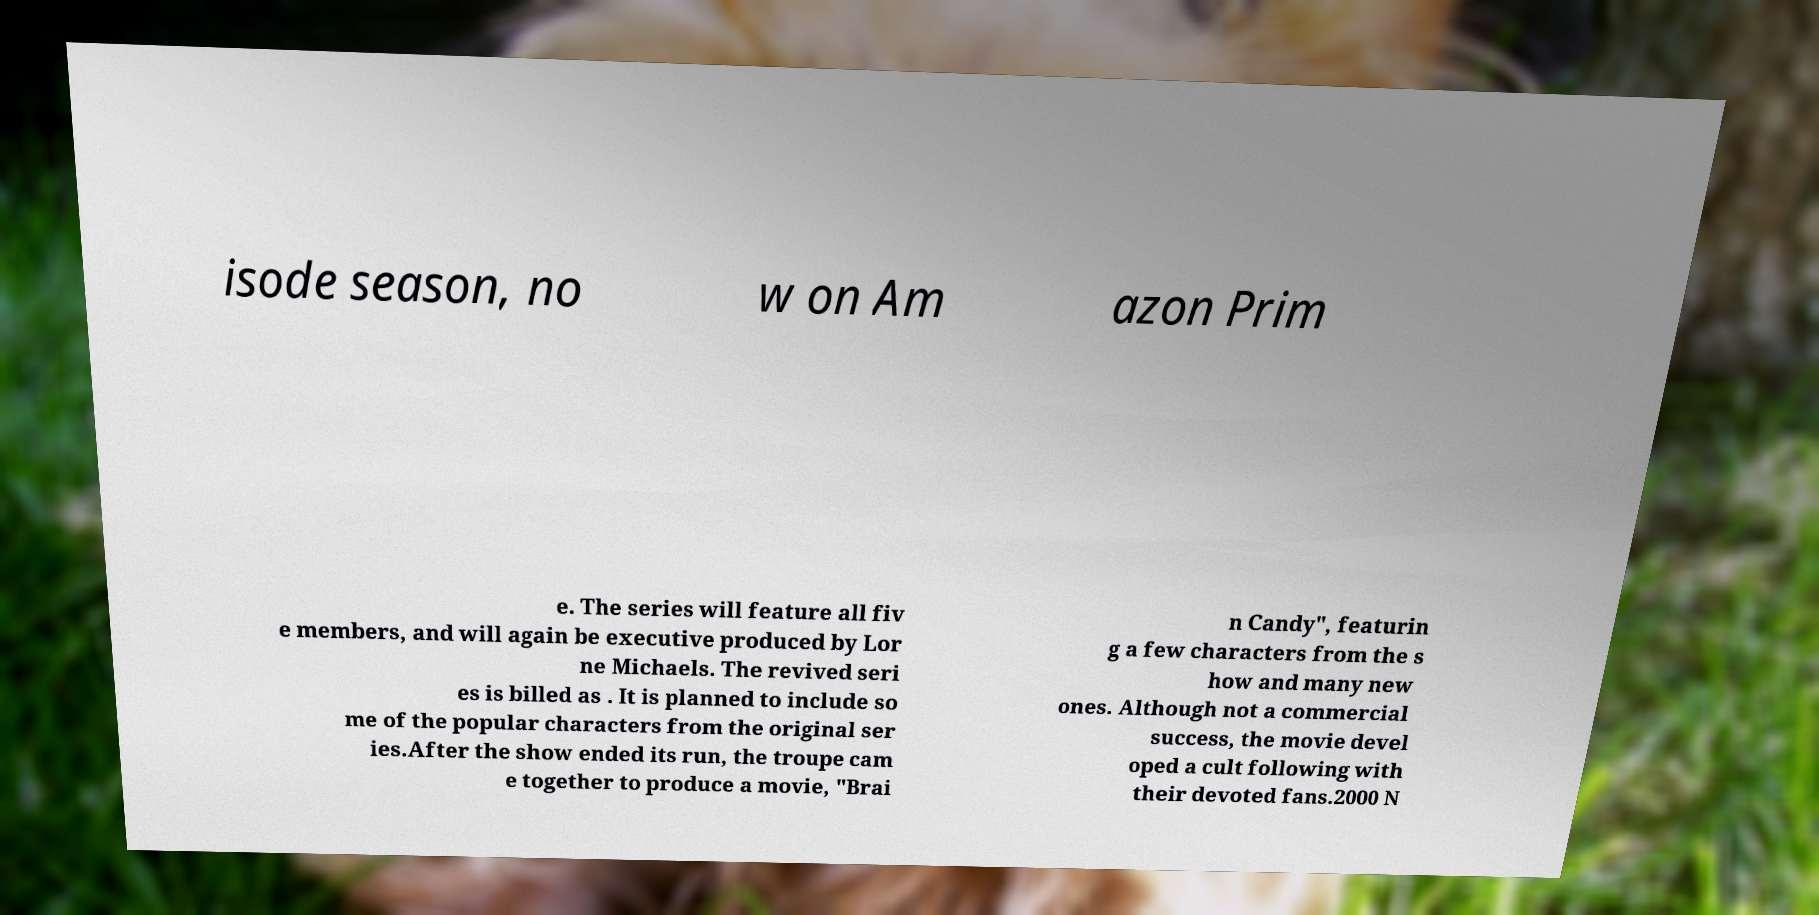I need the written content from this picture converted into text. Can you do that? isode season, no w on Am azon Prim e. The series will feature all fiv e members, and will again be executive produced by Lor ne Michaels. The revived seri es is billed as . It is planned to include so me of the popular characters from the original ser ies.After the show ended its run, the troupe cam e together to produce a movie, "Brai n Candy", featurin g a few characters from the s how and many new ones. Although not a commercial success, the movie devel oped a cult following with their devoted fans.2000 N 